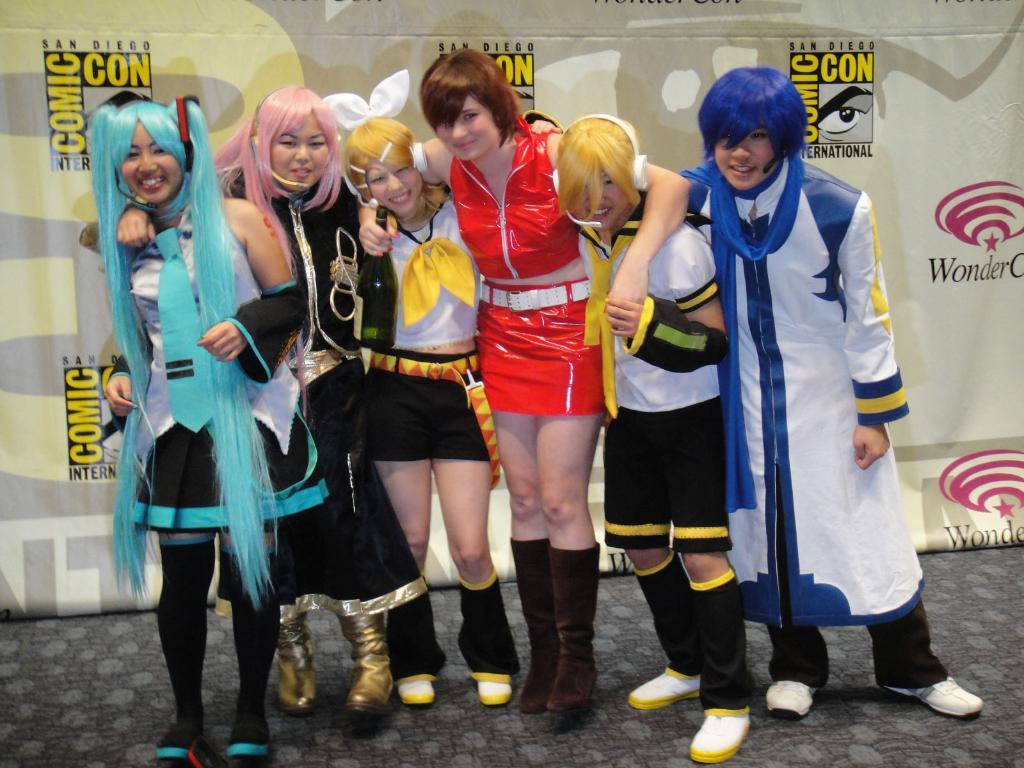What event are these people attending?
Your response must be concise. Comic con. Where is the event located?
Your answer should be compact. San diego. 